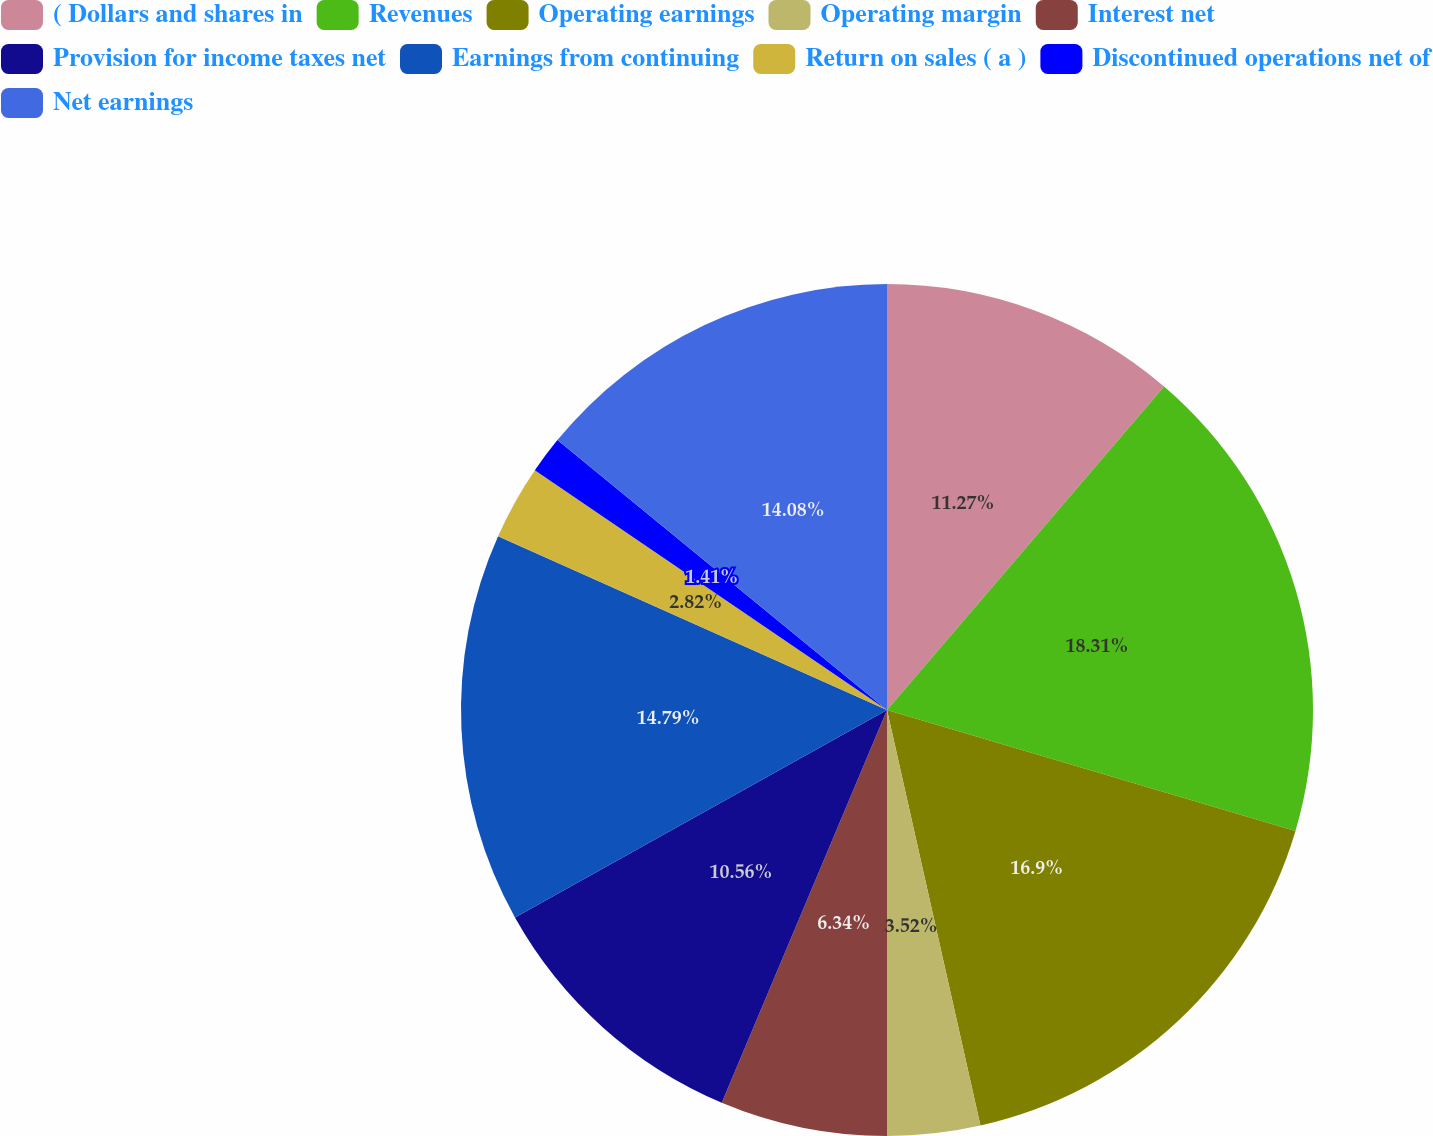Convert chart to OTSL. <chart><loc_0><loc_0><loc_500><loc_500><pie_chart><fcel>( Dollars and shares in<fcel>Revenues<fcel>Operating earnings<fcel>Operating margin<fcel>Interest net<fcel>Provision for income taxes net<fcel>Earnings from continuing<fcel>Return on sales ( a )<fcel>Discontinued operations net of<fcel>Net earnings<nl><fcel>11.27%<fcel>18.31%<fcel>16.9%<fcel>3.52%<fcel>6.34%<fcel>10.56%<fcel>14.79%<fcel>2.82%<fcel>1.41%<fcel>14.08%<nl></chart> 